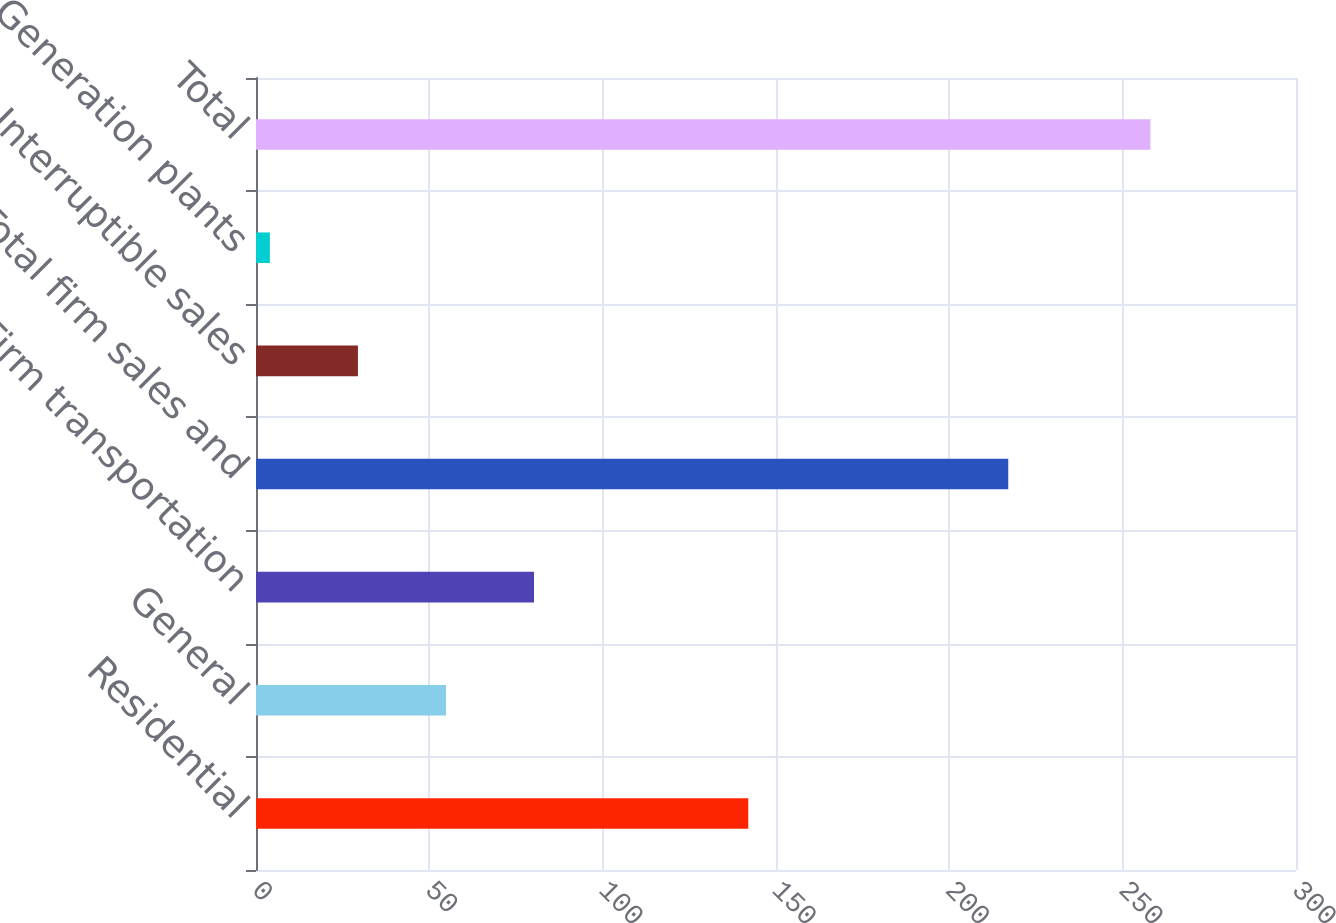Convert chart. <chart><loc_0><loc_0><loc_500><loc_500><bar_chart><fcel>Residential<fcel>General<fcel>Firm transportation<fcel>Total firm sales and<fcel>Interruptible sales<fcel>Generation plants<fcel>Total<nl><fcel>142<fcel>54.8<fcel>80.2<fcel>217<fcel>29.4<fcel>4<fcel>258<nl></chart> 